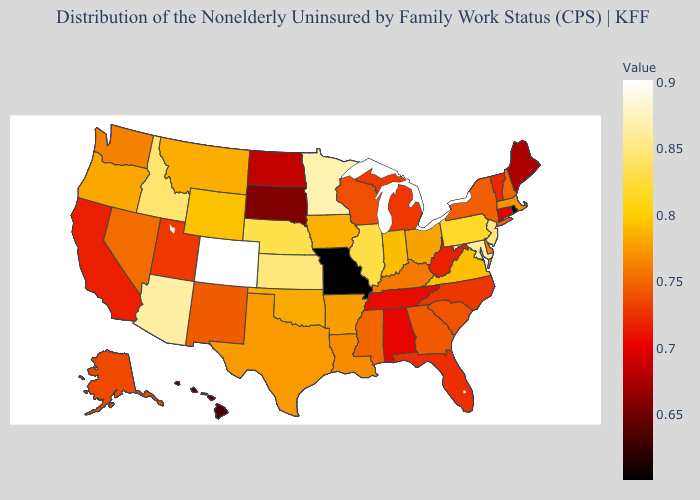Which states hav the highest value in the West?
Concise answer only. Colorado. Among the states that border California , which have the highest value?
Answer briefly. Arizona. Does Colorado have the highest value in the USA?
Quick response, please. Yes. Which states have the highest value in the USA?
Concise answer only. Colorado. 